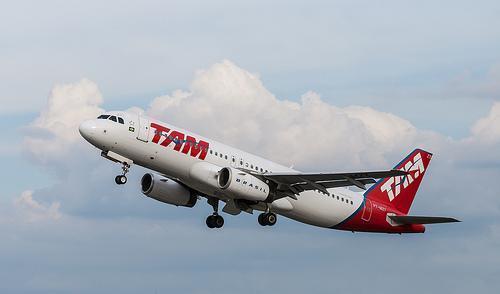How many people are in the photo?
Give a very brief answer. 0. 